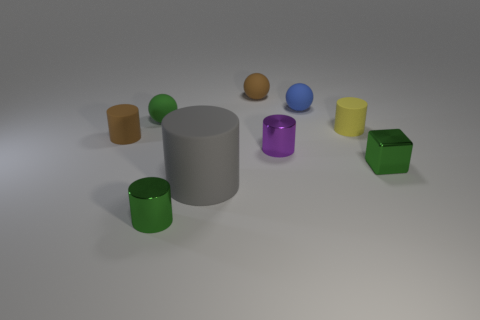There is a brown rubber object that is right of the matte cylinder that is to the left of the ball that is in front of the tiny blue ball; what is its size?
Keep it short and to the point. Small. What is the shape of the tiny green rubber object?
Offer a terse response. Sphere. There is a sphere that is the same color as the tiny block; what size is it?
Your answer should be very brief. Small. How many small green metallic objects are behind the gray rubber thing to the left of the blue matte object?
Your answer should be compact. 1. How many other things are there of the same material as the small brown cylinder?
Keep it short and to the point. 5. Is the tiny green object in front of the gray cylinder made of the same material as the green thing that is to the right of the gray object?
Keep it short and to the point. Yes. Do the tiny green block and the brown thing behind the yellow thing have the same material?
Give a very brief answer. No. The tiny matte cylinder that is right of the brown object in front of the matte cylinder that is right of the blue ball is what color?
Offer a terse response. Yellow. There is a blue object that is the same size as the purple metallic cylinder; what is its shape?
Your answer should be compact. Sphere. Is there any other thing that is the same size as the gray rubber cylinder?
Ensure brevity in your answer.  No. 